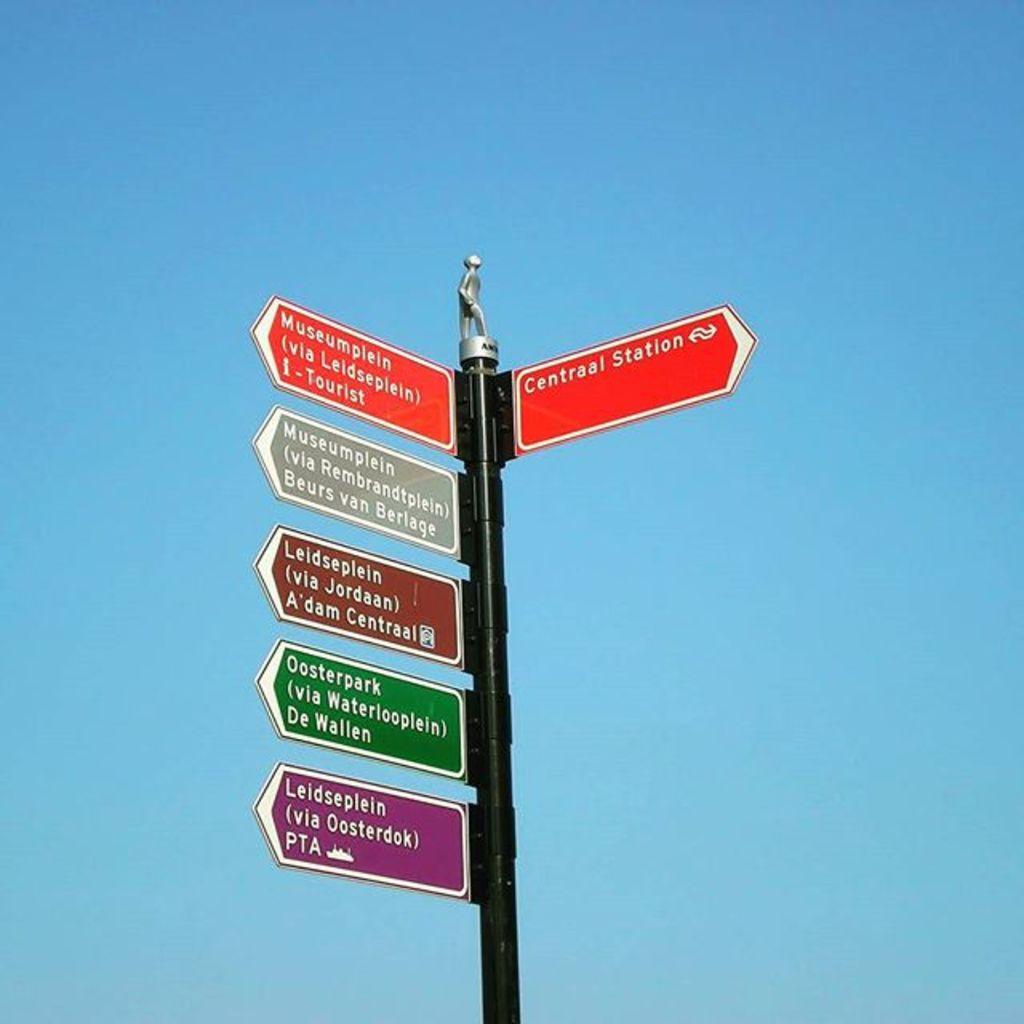What place is to the right?
Give a very brief answer. Central station. If you follow the purple sign where would you end up?
Provide a short and direct response. Leidseplein. 